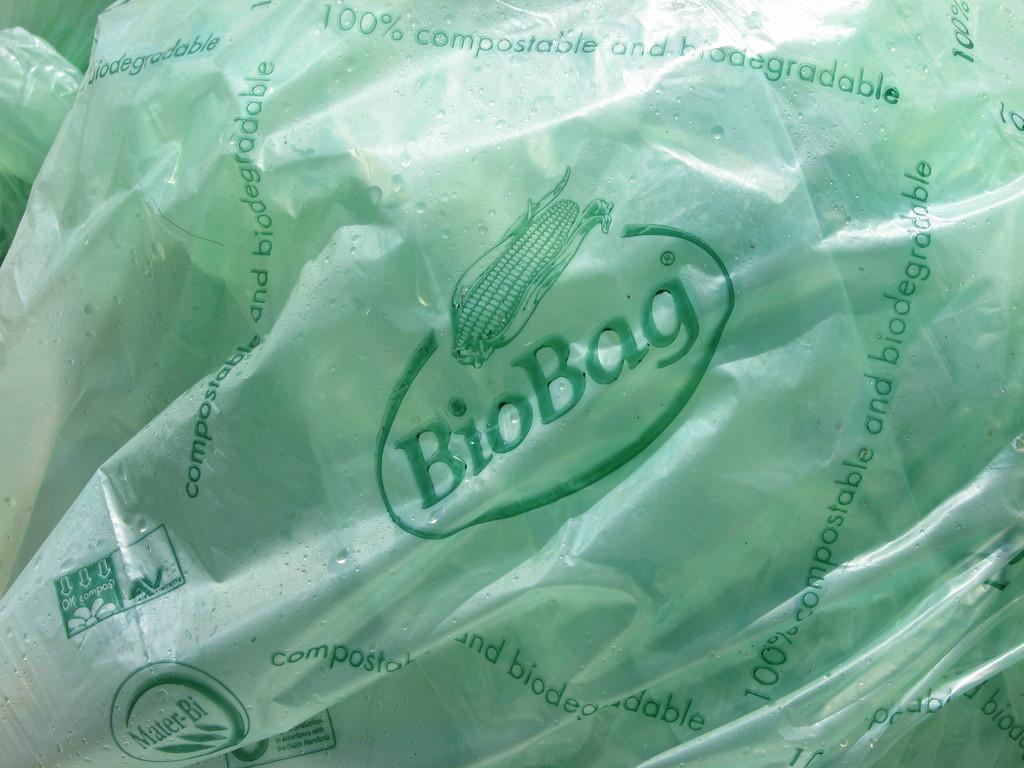Could you give a brief overview of what you see in this image? In the foreground we have plastic cover with label called Mater-Bi and some text. In the middle we have a label called Bio Bag with corn Symbol. On the top most we have text like 100% compostable and biodegradable. 